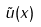Convert formula to latex. <formula><loc_0><loc_0><loc_500><loc_500>\tilde { u } ( x )</formula> 